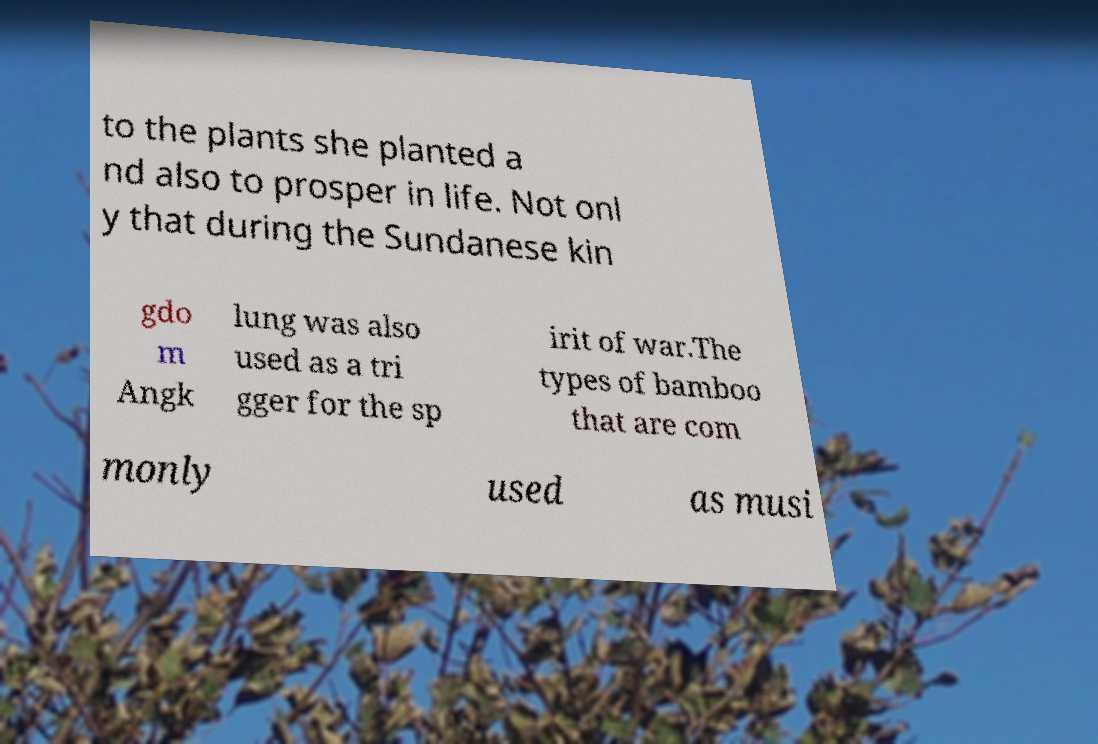Please identify and transcribe the text found in this image. to the plants she planted a nd also to prosper in life. Not onl y that during the Sundanese kin gdo m Angk lung was also used as a tri gger for the sp irit of war.The types of bamboo that are com monly used as musi 